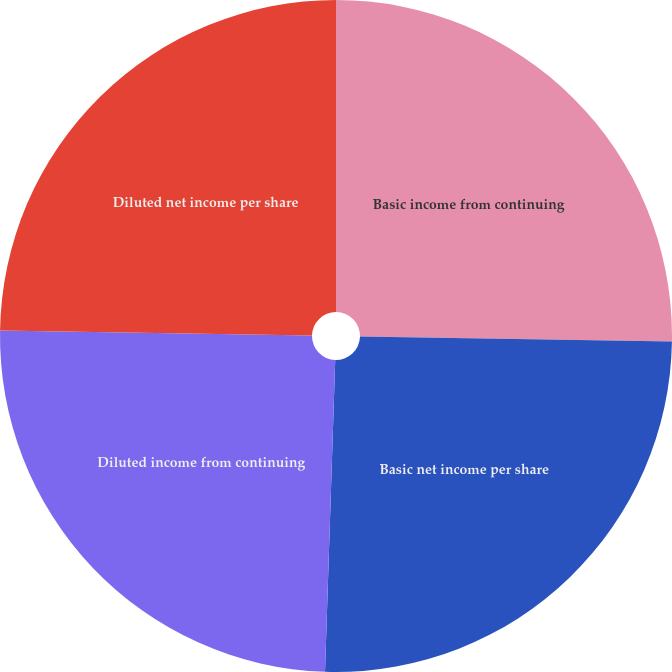<chart> <loc_0><loc_0><loc_500><loc_500><pie_chart><fcel>Basic income from continuing<fcel>Basic net income per share<fcel>Diluted income from continuing<fcel>Diluted net income per share<nl><fcel>25.26%<fcel>25.26%<fcel>24.74%<fcel>24.74%<nl></chart> 